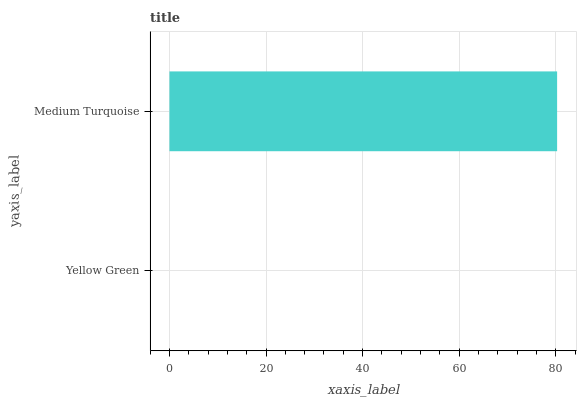Is Yellow Green the minimum?
Answer yes or no. Yes. Is Medium Turquoise the maximum?
Answer yes or no. Yes. Is Medium Turquoise the minimum?
Answer yes or no. No. Is Medium Turquoise greater than Yellow Green?
Answer yes or no. Yes. Is Yellow Green less than Medium Turquoise?
Answer yes or no. Yes. Is Yellow Green greater than Medium Turquoise?
Answer yes or no. No. Is Medium Turquoise less than Yellow Green?
Answer yes or no. No. Is Medium Turquoise the high median?
Answer yes or no. Yes. Is Yellow Green the low median?
Answer yes or no. Yes. Is Yellow Green the high median?
Answer yes or no. No. Is Medium Turquoise the low median?
Answer yes or no. No. 